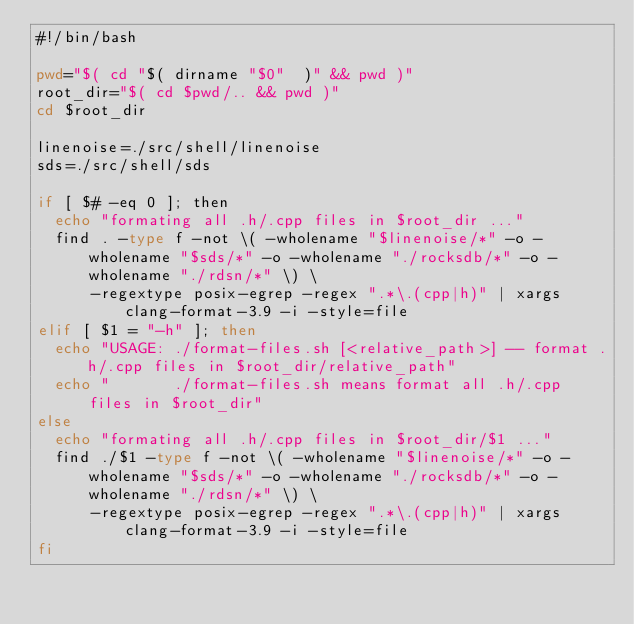Convert code to text. <code><loc_0><loc_0><loc_500><loc_500><_Bash_>#!/bin/bash

pwd="$( cd "$( dirname "$0"  )" && pwd )"
root_dir="$( cd $pwd/.. && pwd )"
cd $root_dir

linenoise=./src/shell/linenoise
sds=./src/shell/sds

if [ $# -eq 0 ]; then
  echo "formating all .h/.cpp files in $root_dir ..."
  find . -type f -not \( -wholename "$linenoise/*" -o -wholename "$sds/*" -o -wholename "./rocksdb/*" -o -wholename "./rdsn/*" \) \
      -regextype posix-egrep -regex ".*\.(cpp|h)" | xargs clang-format-3.9 -i -style=file
elif [ $1 = "-h" ]; then
  echo "USAGE: ./format-files.sh [<relative_path>] -- format .h/.cpp files in $root_dir/relative_path"
  echo "       ./format-files.sh means format all .h/.cpp files in $root_dir"
else
  echo "formating all .h/.cpp files in $root_dir/$1 ..."
  find ./$1 -type f -not \( -wholename "$linenoise/*" -o -wholename "$sds/*" -o -wholename "./rocksdb/*" -o -wholename "./rdsn/*" \) \
      -regextype posix-egrep -regex ".*\.(cpp|h)" | xargs clang-format-3.9 -i -style=file
fi

</code> 